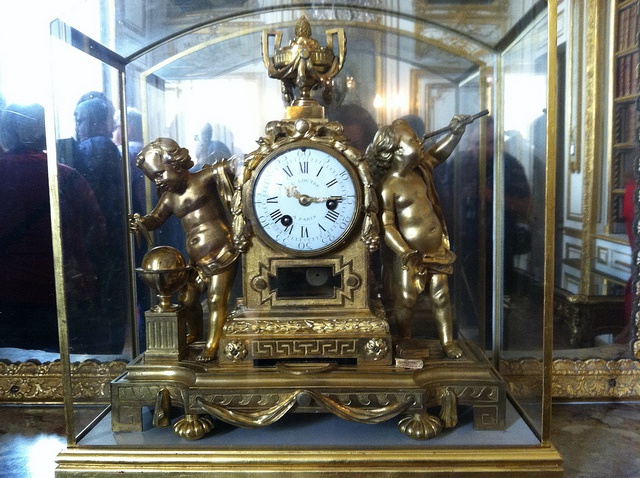Describe the objects in this image and their specific colors. I can see people in white, black, navy, gray, and darkblue tones, clock in white, lightblue, gray, and darkgray tones, people in white, black, gray, and darkgray tones, people in white, black, navy, gray, and darkblue tones, and people in white, gray, and black tones in this image. 